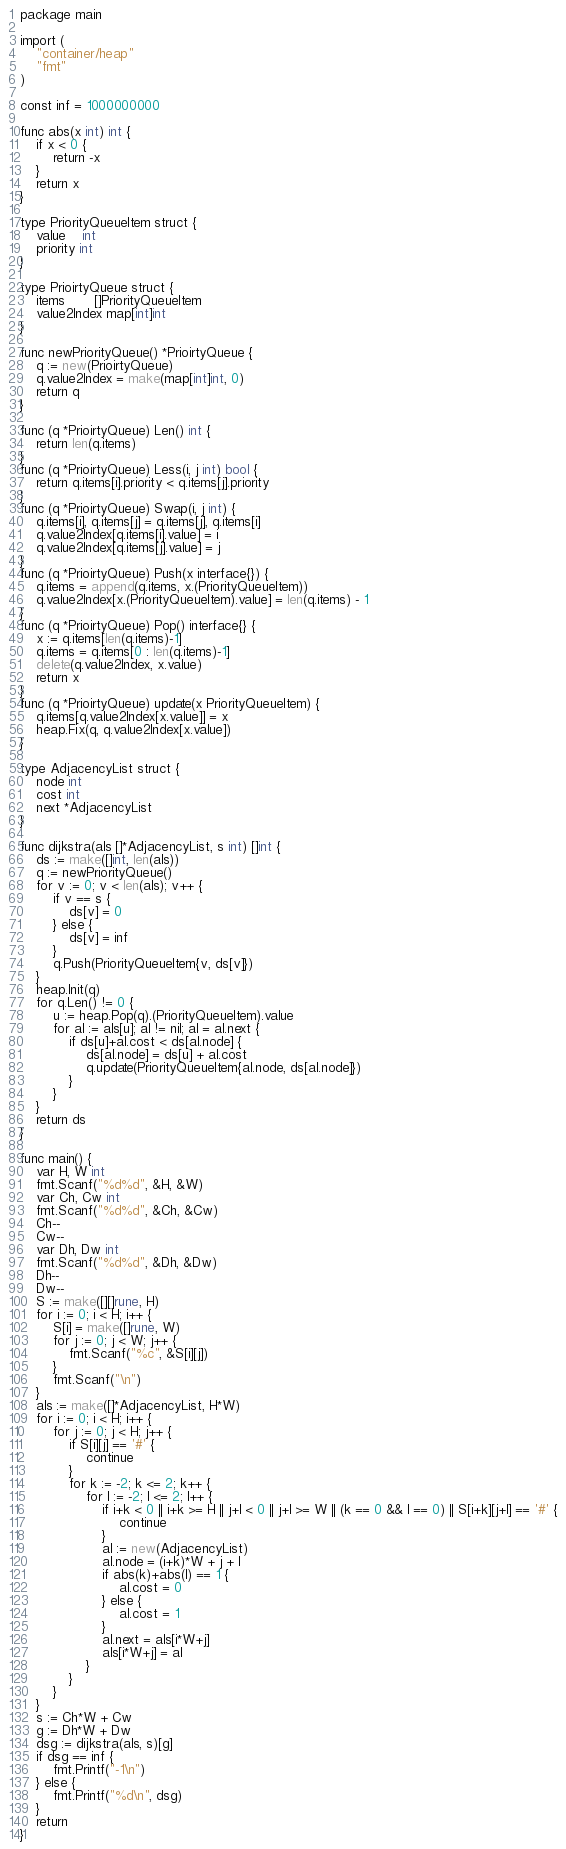Convert code to text. <code><loc_0><loc_0><loc_500><loc_500><_Go_>package main

import (
	"container/heap"
	"fmt"
)

const inf = 1000000000

func abs(x int) int {
	if x < 0 {
		return -x
	}
	return x
}

type PriorityQueueItem struct {
	value    int
	priority int
}

type PrioirtyQueue struct {
	items       []PriorityQueueItem
	value2Index map[int]int
}

func newPriorityQueue() *PrioirtyQueue {
	q := new(PrioirtyQueue)
	q.value2Index = make(map[int]int, 0)
	return q
}

func (q *PrioirtyQueue) Len() int {
	return len(q.items)
}
func (q *PrioirtyQueue) Less(i, j int) bool {
	return q.items[i].priority < q.items[j].priority
}
func (q *PrioirtyQueue) Swap(i, j int) {
	q.items[i], q.items[j] = q.items[j], q.items[i]
	q.value2Index[q.items[i].value] = i
	q.value2Index[q.items[j].value] = j
}
func (q *PrioirtyQueue) Push(x interface{}) {
	q.items = append(q.items, x.(PriorityQueueItem))
	q.value2Index[x.(PriorityQueueItem).value] = len(q.items) - 1
}
func (q *PrioirtyQueue) Pop() interface{} {
	x := q.items[len(q.items)-1]
	q.items = q.items[0 : len(q.items)-1]
	delete(q.value2Index, x.value)
	return x
}
func (q *PrioirtyQueue) update(x PriorityQueueItem) {
	q.items[q.value2Index[x.value]] = x
	heap.Fix(q, q.value2Index[x.value])
}

type AdjacencyList struct {
	node int
	cost int
	next *AdjacencyList
}

func dijkstra(als []*AdjacencyList, s int) []int {
	ds := make([]int, len(als))
	q := newPriorityQueue()
	for v := 0; v < len(als); v++ {
		if v == s {
			ds[v] = 0
		} else {
			ds[v] = inf
		}
		q.Push(PriorityQueueItem{v, ds[v]})
	}
	heap.Init(q)
	for q.Len() != 0 {
		u := heap.Pop(q).(PriorityQueueItem).value
		for al := als[u]; al != nil; al = al.next {
			if ds[u]+al.cost < ds[al.node] {
				ds[al.node] = ds[u] + al.cost
				q.update(PriorityQueueItem{al.node, ds[al.node]})
			}
		}
	}
	return ds
}

func main() {
	var H, W int
	fmt.Scanf("%d%d", &H, &W)
	var Ch, Cw int
	fmt.Scanf("%d%d", &Ch, &Cw)
	Ch--
	Cw--
	var Dh, Dw int
	fmt.Scanf("%d%d", &Dh, &Dw)
	Dh--
	Dw--
	S := make([][]rune, H)
	for i := 0; i < H; i++ {
		S[i] = make([]rune, W)
		for j := 0; j < W; j++ {
			fmt.Scanf("%c", &S[i][j])
		}
		fmt.Scanf("\n")
	}
	als := make([]*AdjacencyList, H*W)
	for i := 0; i < H; i++ {
		for j := 0; j < H; j++ {
			if S[i][j] == '#' {
				continue
			}
			for k := -2; k <= 2; k++ {
				for l := -2; l <= 2; l++ {
					if i+k < 0 || i+k >= H || j+l < 0 || j+l >= W || (k == 0 && l == 0) || S[i+k][j+l] == '#' {
						continue
					}
					al := new(AdjacencyList)
					al.node = (i+k)*W + j + l
					if abs(k)+abs(l) == 1 {
						al.cost = 0
					} else {
						al.cost = 1
					}
					al.next = als[i*W+j]
					als[i*W+j] = al
				}
			}
		}
	}
	s := Ch*W + Cw
	g := Dh*W + Dw
	dsg := dijkstra(als, s)[g]
	if dsg == inf {
		fmt.Printf("-1\n")
	} else {
		fmt.Printf("%d\n", dsg)
	}
	return
}
</code> 